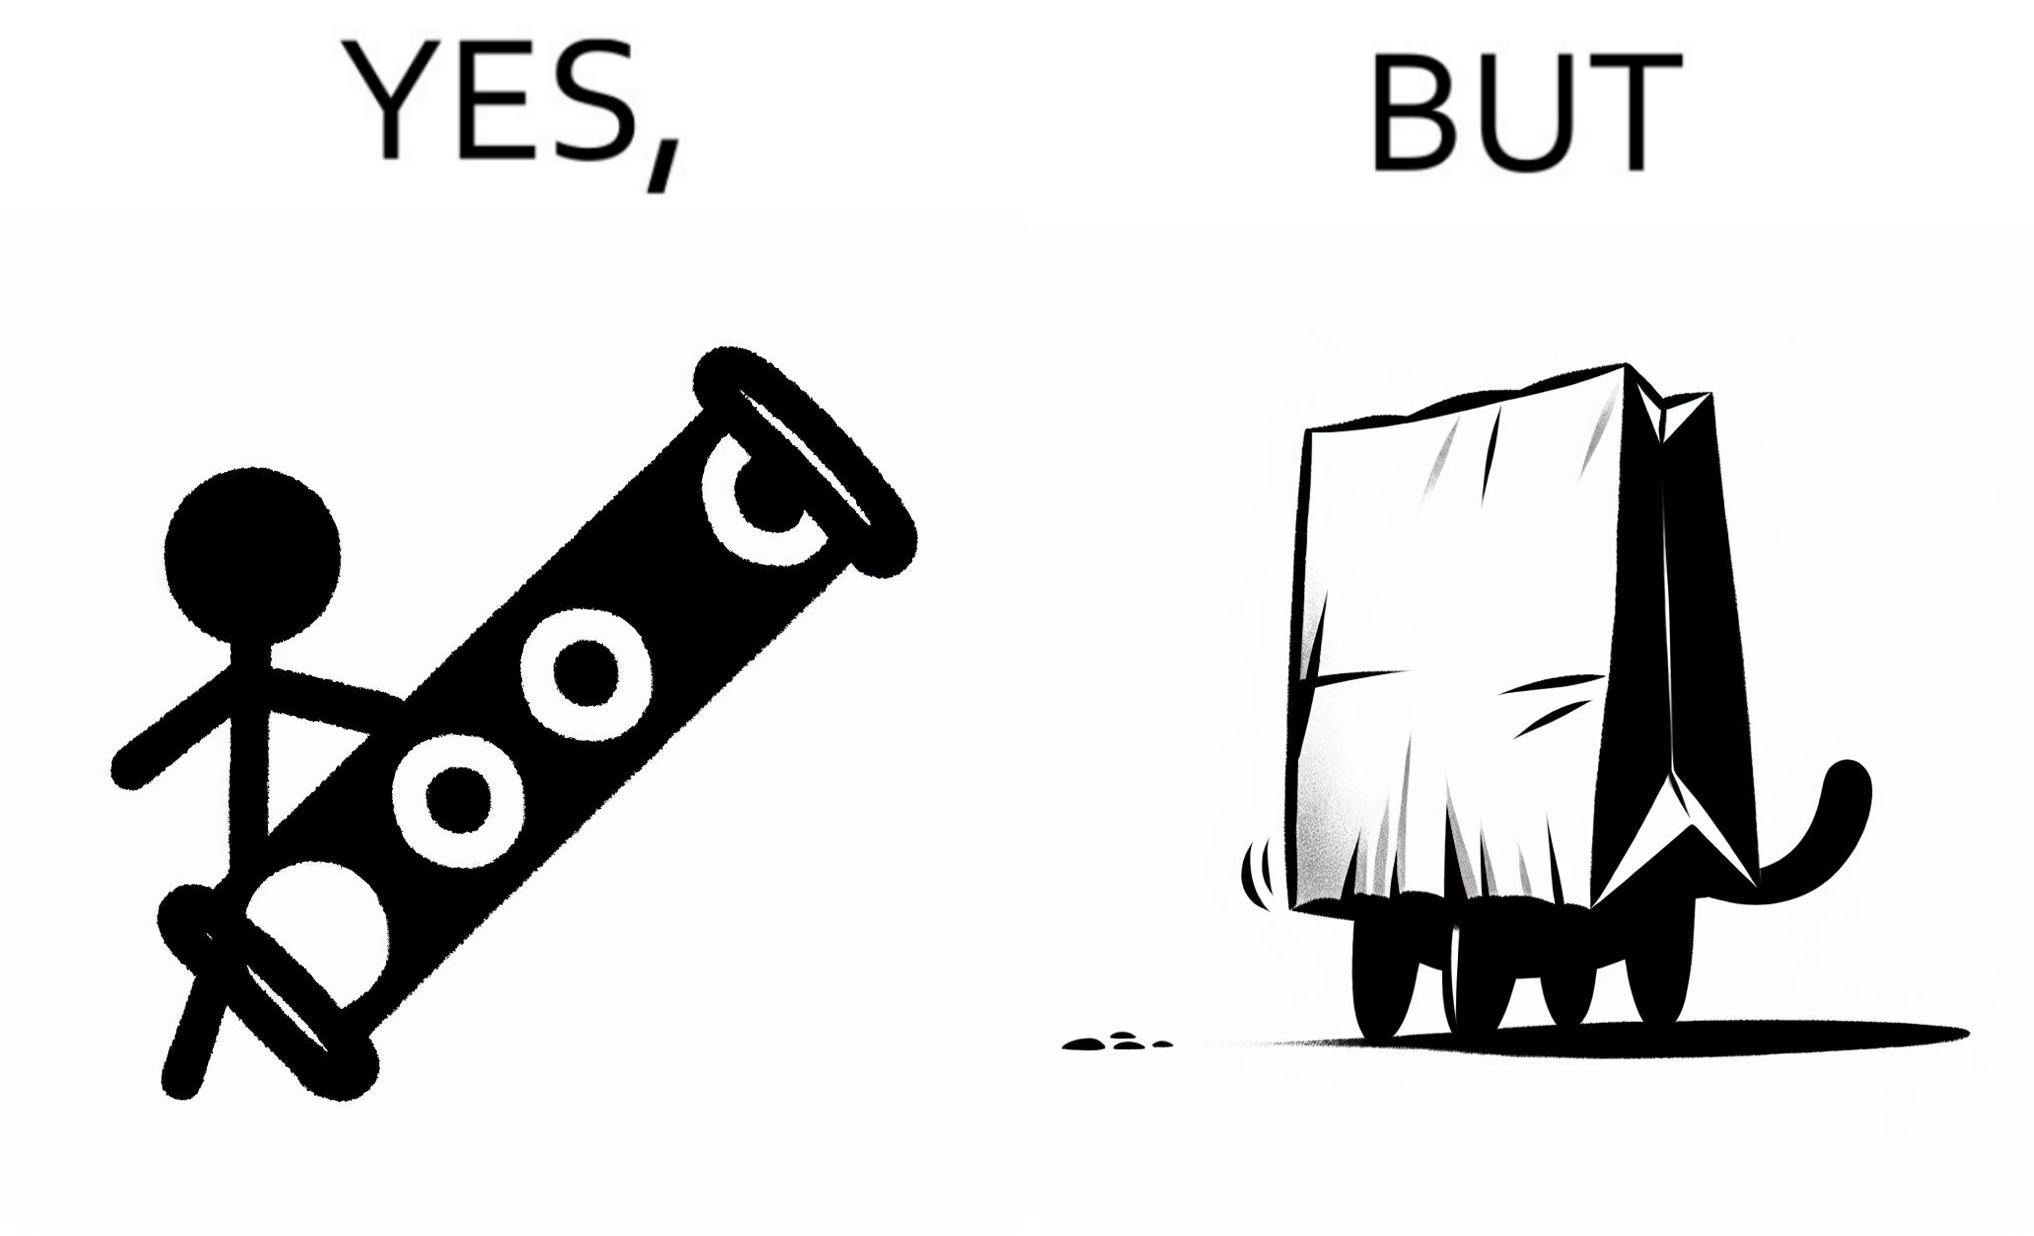What do you see in each half of this image? In the left part of the image: a long piece of cylinder with two circular holes over its surface and two holes at top and bottom and a hanging toy at one end In the right part of the image: an animal hiding its face in a paper bag, probably a cat or dog 